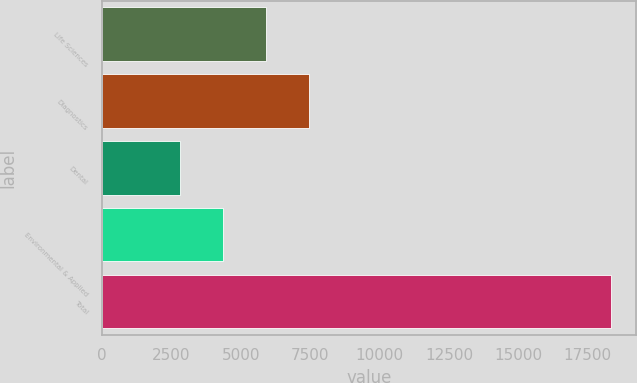Convert chart. <chart><loc_0><loc_0><loc_500><loc_500><bar_chart><fcel>Life Sciences<fcel>Diagnostics<fcel>Dental<fcel>Environmental & Applied<fcel>Total<nl><fcel>5914.66<fcel>7466.54<fcel>2810.9<fcel>4362.78<fcel>18329.7<nl></chart> 